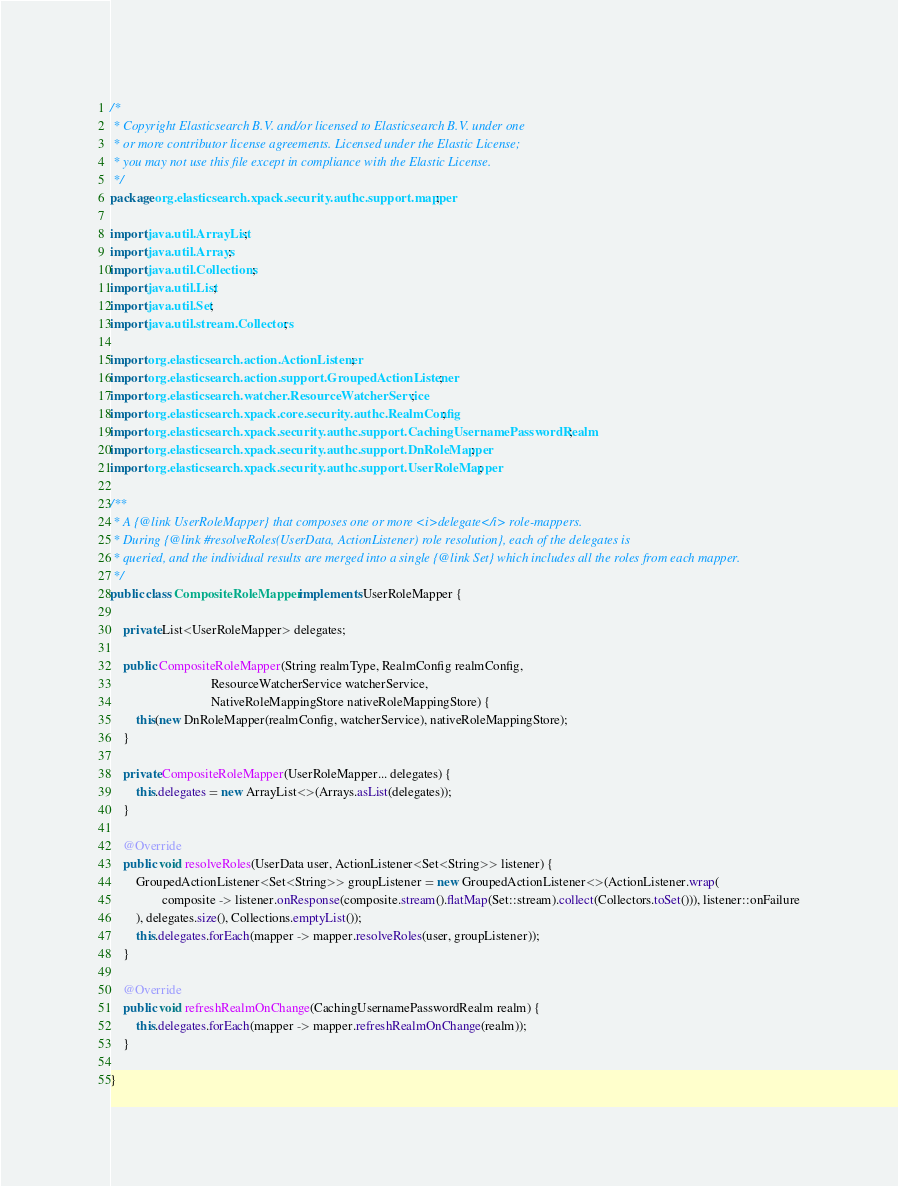Convert code to text. <code><loc_0><loc_0><loc_500><loc_500><_Java_>/*
 * Copyright Elasticsearch B.V. and/or licensed to Elasticsearch B.V. under one
 * or more contributor license agreements. Licensed under the Elastic License;
 * you may not use this file except in compliance with the Elastic License.
 */
package org.elasticsearch.xpack.security.authc.support.mapper;

import java.util.ArrayList;
import java.util.Arrays;
import java.util.Collections;
import java.util.List;
import java.util.Set;
import java.util.stream.Collectors;

import org.elasticsearch.action.ActionListener;
import org.elasticsearch.action.support.GroupedActionListener;
import org.elasticsearch.watcher.ResourceWatcherService;
import org.elasticsearch.xpack.core.security.authc.RealmConfig;
import org.elasticsearch.xpack.security.authc.support.CachingUsernamePasswordRealm;
import org.elasticsearch.xpack.security.authc.support.DnRoleMapper;
import org.elasticsearch.xpack.security.authc.support.UserRoleMapper;

/**
 * A {@link UserRoleMapper} that composes one or more <i>delegate</i> role-mappers.
 * During {@link #resolveRoles(UserData, ActionListener) role resolution}, each of the delegates is
 * queried, and the individual results are merged into a single {@link Set} which includes all the roles from each mapper.
 */
public class CompositeRoleMapper implements UserRoleMapper {

    private List<UserRoleMapper> delegates;

    public CompositeRoleMapper(String realmType, RealmConfig realmConfig,
                               ResourceWatcherService watcherService,
                               NativeRoleMappingStore nativeRoleMappingStore) {
        this(new DnRoleMapper(realmConfig, watcherService), nativeRoleMappingStore);
    }

    private CompositeRoleMapper(UserRoleMapper... delegates) {
        this.delegates = new ArrayList<>(Arrays.asList(delegates));
    }

    @Override
    public void resolveRoles(UserData user, ActionListener<Set<String>> listener) {
        GroupedActionListener<Set<String>> groupListener = new GroupedActionListener<>(ActionListener.wrap(
                composite -> listener.onResponse(composite.stream().flatMap(Set::stream).collect(Collectors.toSet())), listener::onFailure
        ), delegates.size(), Collections.emptyList());
        this.delegates.forEach(mapper -> mapper.resolveRoles(user, groupListener));
    }

    @Override
    public void refreshRealmOnChange(CachingUsernamePasswordRealm realm) {
        this.delegates.forEach(mapper -> mapper.refreshRealmOnChange(realm));
    }

}
</code> 